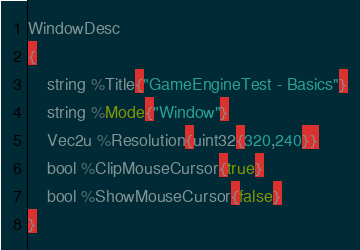Convert code to text. <code><loc_0><loc_0><loc_500><loc_500><_SQL_>WindowDesc
{
	string %Title{"GameEngineTest - Basics"}
	string %Mode{"Window"}
	Vec2u %Resolution{uint32{320,240}}
	bool %ClipMouseCursor{true}
	bool %ShowMouseCursor{false}
}
</code> 